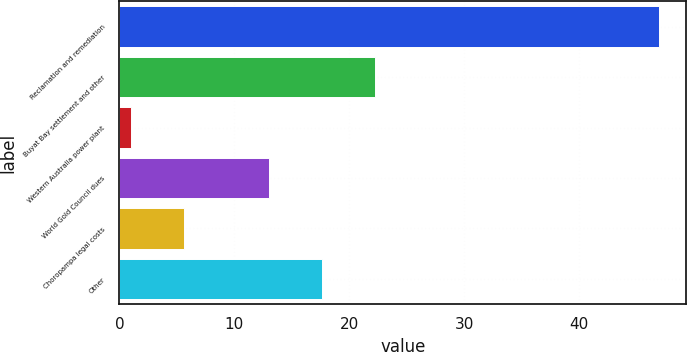Convert chart to OTSL. <chart><loc_0><loc_0><loc_500><loc_500><bar_chart><fcel>Reclamation and remediation<fcel>Buyat Bay settlement and other<fcel>Western Australia power plant<fcel>World Gold Council dues<fcel>Choropampa legal costs<fcel>Other<nl><fcel>47<fcel>22.2<fcel>1<fcel>13<fcel>5.6<fcel>17.6<nl></chart> 